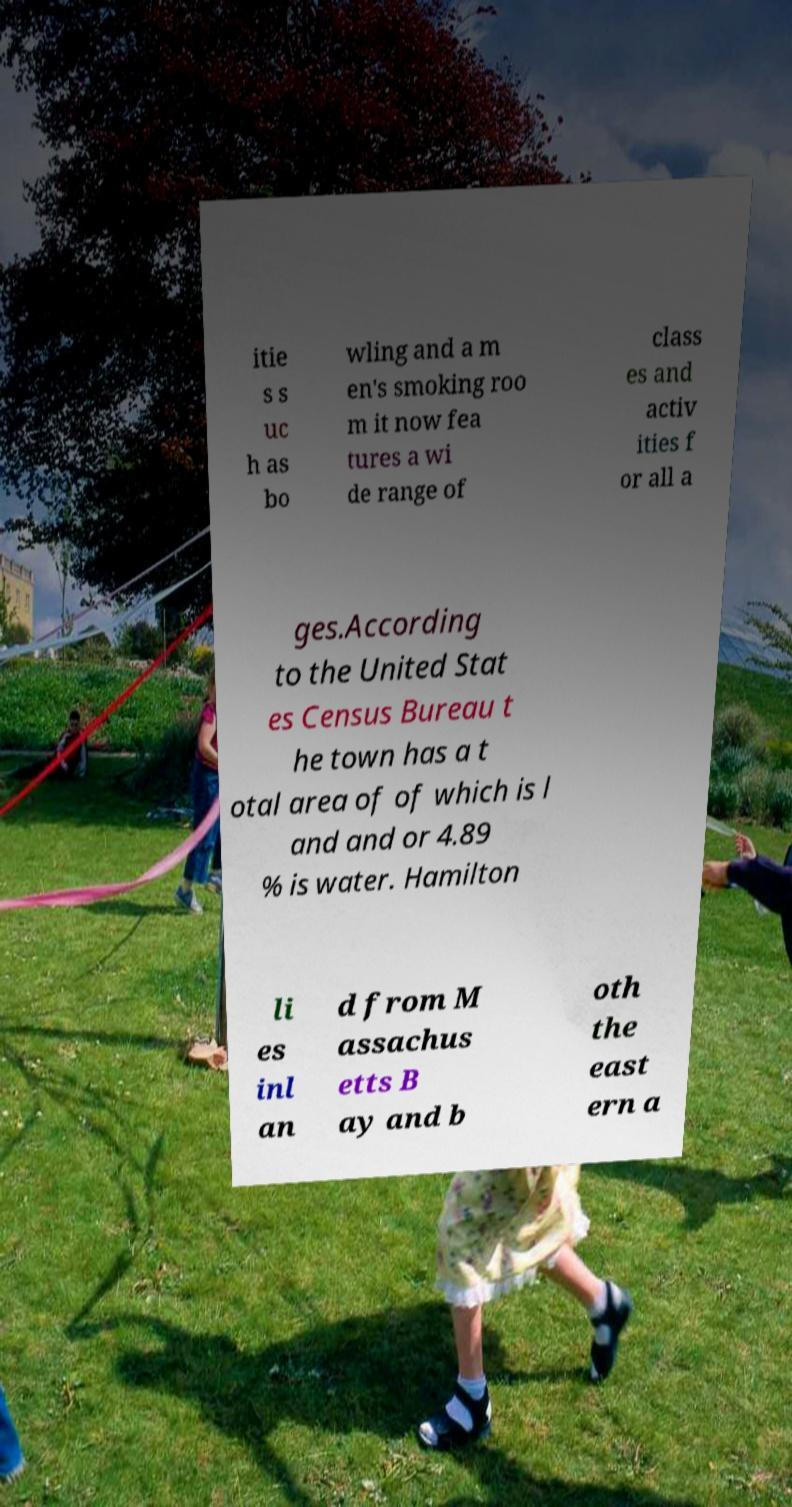I need the written content from this picture converted into text. Can you do that? itie s s uc h as bo wling and a m en's smoking roo m it now fea tures a wi de range of class es and activ ities f or all a ges.According to the United Stat es Census Bureau t he town has a t otal area of of which is l and and or 4.89 % is water. Hamilton li es inl an d from M assachus etts B ay and b oth the east ern a 